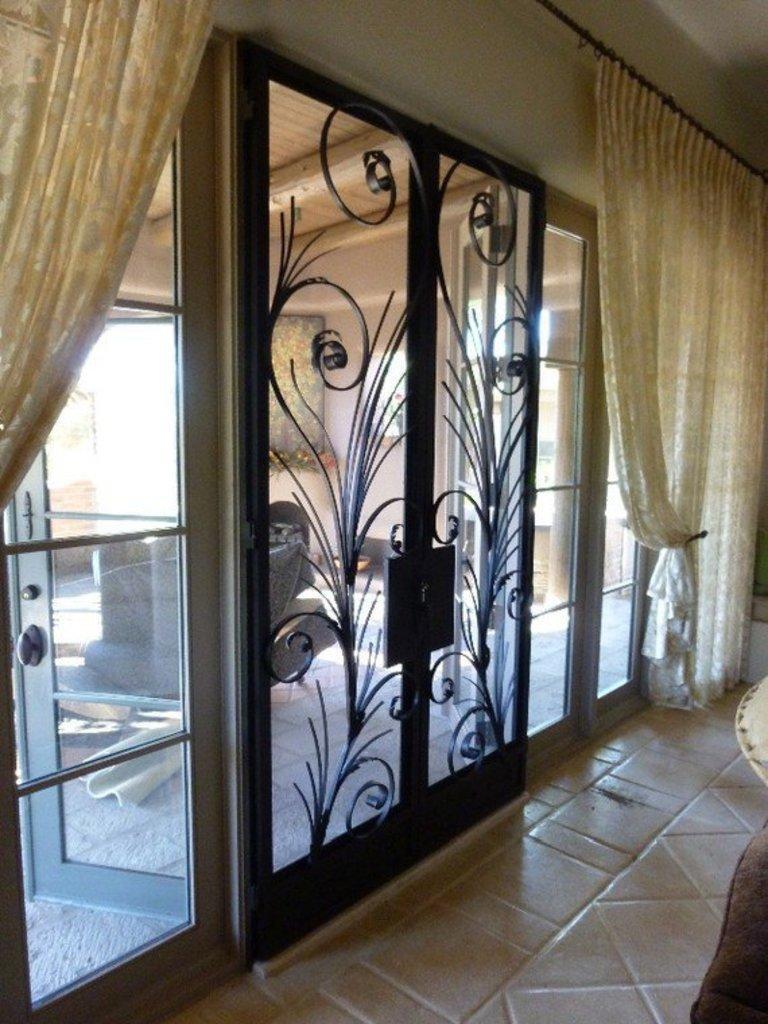How would you summarize this image in a sentence or two? In this picture i can see the inside view of the house. On the left i can see the windows and doors. Behind the door i can see the couch. In the bottom right corner there is a table and chair. On the right i can see the cloth which is hanging from this pipe. 